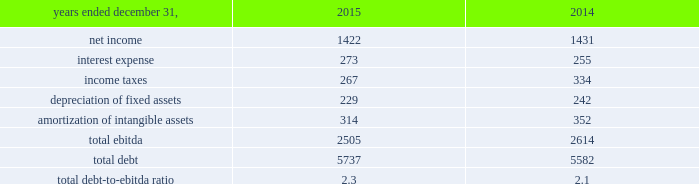On may 20 , 2015 , aon plc issued $ 600 million of 4.750% ( 4.750 % ) senior notes due may 2045 .
The 4.750% ( 4.750 % ) notes due may 2045 are fully and unconditionally guaranteed by aon corporation .
We used the proceeds of the issuance for general corporate purposes .
On september 30 , 2015 , $ 600 million of 3.50% ( 3.50 % ) senior notes issued by aon corporation matured and were repaid .
On november 13 , 2015 , aon plc issued $ 400 million of 2.80% ( 2.80 % ) senior notes due march 2021 .
The 2.80% ( 2.80 % ) notes due march 2021 are fully and unconditionally guaranteed by aon corporation .
We used the proceeds of the issuance for general corporate purposes .
Credit facilities as of december 31 , 2015 , we had two committed credit facilities outstanding : our $ 400 million u.s .
Credit facility expiring in march 2017 ( the "2017 facility" ) and $ 900 million multi-currency u.s .
Credit facility expiring in february 2020 ( the "2020 facility" ) .
The 2020 facility was entered into on february 2 , 2015 and replaced the previous 20ac650 million european credit facility .
Each of these facilities is intended to support our commercial paper obligations and our general working capital needs .
In addition , each of these facilities includes customary representations , warranties and covenants , including financial covenants that require us to maintain specified ratios of adjusted consolidated ebitda to consolidated interest expense and consolidated debt to adjusted consolidated ebitda , tested quarterly .
At december 31 , 2015 , we did not have borrowings under either the 2017 facility or the 2020 facility , and we were in compliance with the financial covenants and all other covenants contained therein during the twelve months ended december 31 , 2015 .
Effective february 2 , 2016 , the 2020 facility terms were extended for 1 year and will expire in february 2021 our total debt-to-ebitda ratio at december 31 , 2015 and 2014 , is calculated as follows: .
We use ebitda , as defined by our financial covenants , as a non-gaap measure .
This supplemental information related to ebitda represents a measure not in accordance with u.s .
Gaap and should be viewed in addition to , not instead of , our consolidated financial statements and notes thereto .
Shelf registration statement on september 3 , 2015 , we filed a shelf registration statement with the sec , registering the offer and sale from time to time of an indeterminate amount of , among other securities , debt securities , preference shares , class a ordinary shares and convertible securities .
Our ability to access the market as a source of liquidity is dependent on investor demand , market conditions and other factors. .
What was the ratio of the 2017 credit facility to the 2020 credit facility? 
Computations: (900 / 400)
Answer: 2.25. 